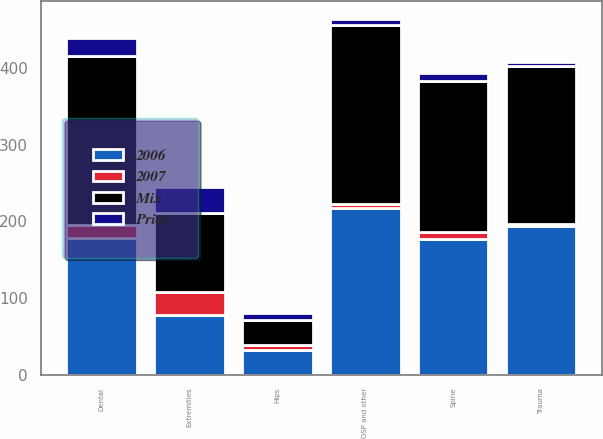Convert chart. <chart><loc_0><loc_0><loc_500><loc_500><stacked_bar_chart><ecel><fcel>Hips<fcel>Extremities<fcel>Dental<fcel>Trauma<fcel>Spine<fcel>OSP and other<nl><fcel>Mix<fcel>32<fcel>104<fcel>221<fcel>205.8<fcel>197<fcel>233.9<nl><fcel>2006<fcel>32<fcel>77.6<fcel>179<fcel>194.7<fcel>177.4<fcel>217.3<nl><fcel>Price<fcel>9<fcel>34<fcel>23<fcel>6<fcel>11<fcel>8<nl><fcel>2007<fcel>7<fcel>30<fcel>16<fcel>2<fcel>9<fcel>5<nl></chart> 